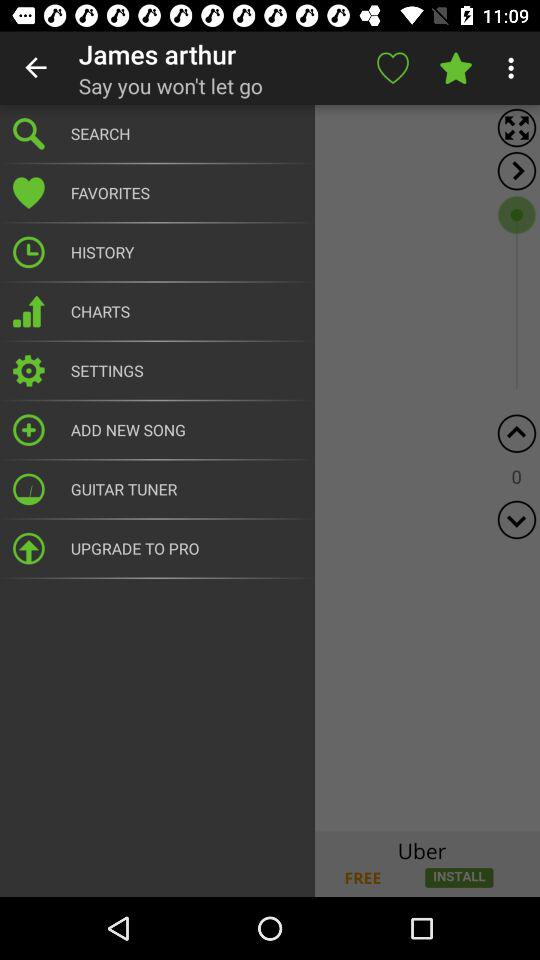What is the user name? The user name is James Arthur. 